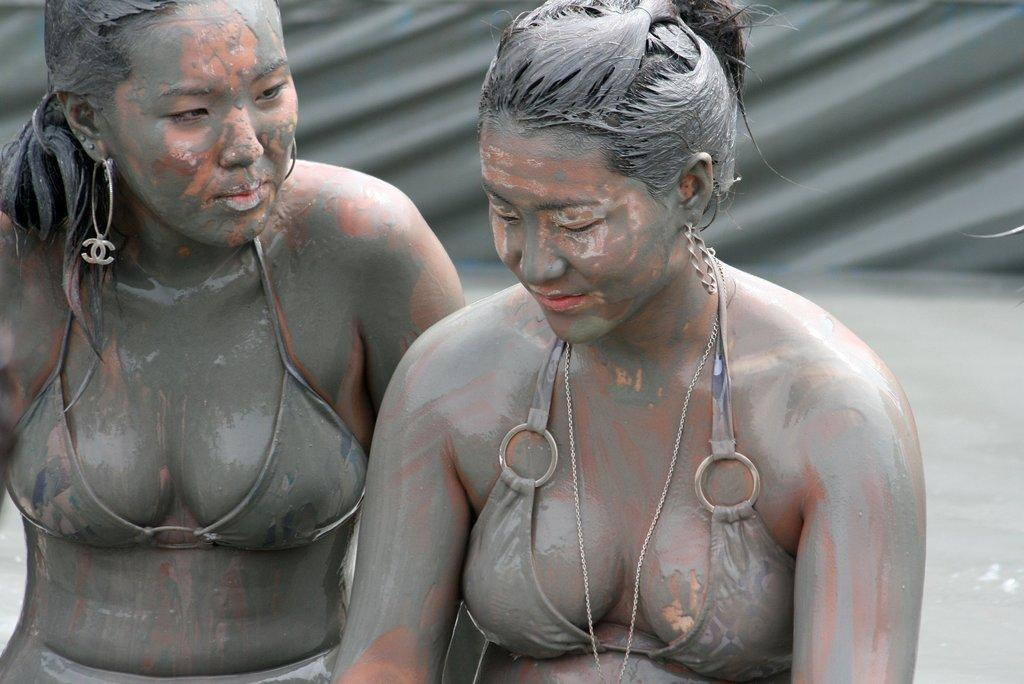How many people are in the image? There are two women in the image. What is the condition of the ground in the image? There is mud visible in the image. What type of room can be seen in the image? There is no room visible in the image; it appears to be an outdoor scene with mud. 